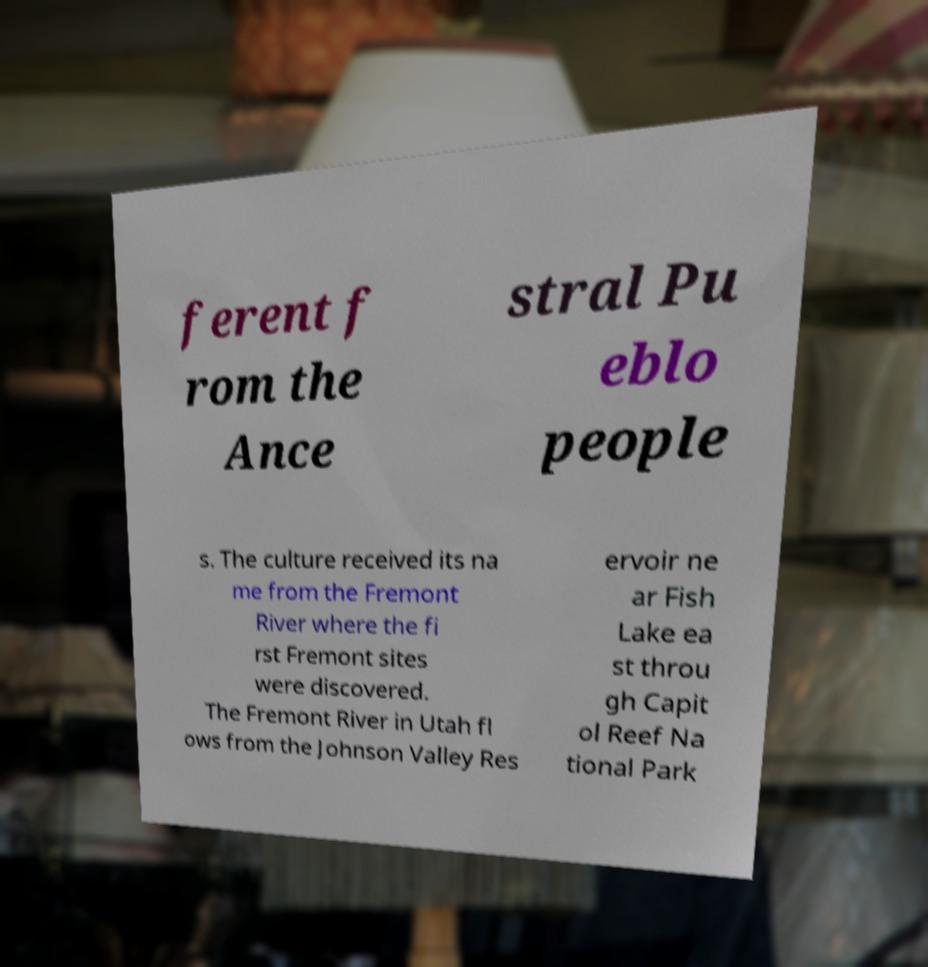Please read and relay the text visible in this image. What does it say? ferent f rom the Ance stral Pu eblo people s. The culture received its na me from the Fremont River where the fi rst Fremont sites were discovered. The Fremont River in Utah fl ows from the Johnson Valley Res ervoir ne ar Fish Lake ea st throu gh Capit ol Reef Na tional Park 